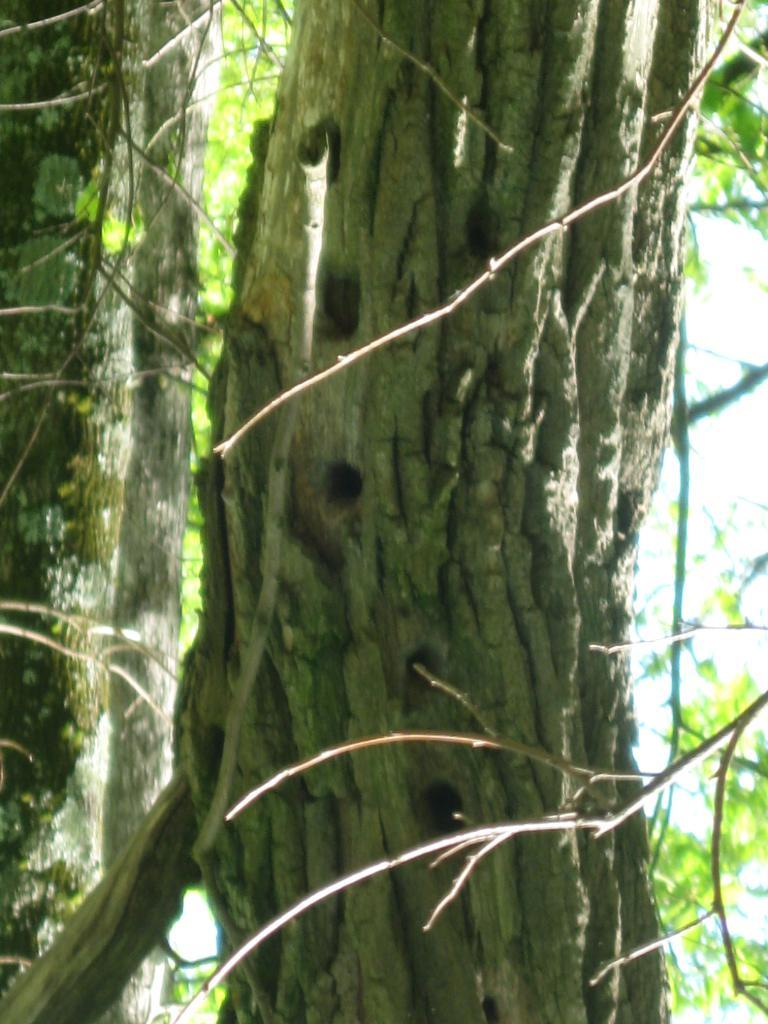What is the main subject of the image? The main subject of the image is a tree trunk. Can you describe the background of the image? The background of the image is slightly blurred. What type of map can be seen on the tree trunk in the image? There is no map present on the tree trunk in the image. What sense is being used to perceive the tree trunk in the image? The sense of sight is being used to perceive the tree trunk in the image. 